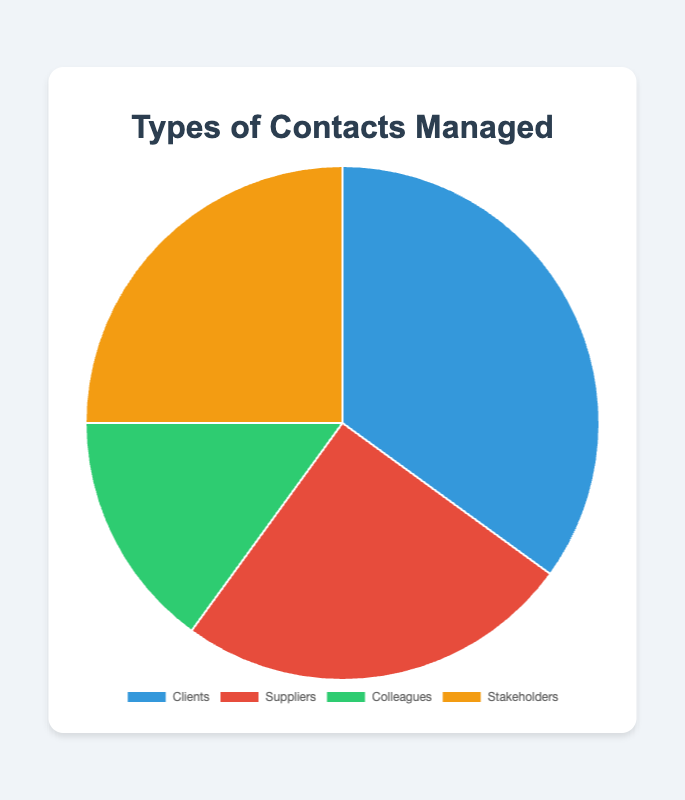What is the percentage of each contact type? From the visual, Clients, Suppliers, Colleagues, and Stakeholders are represented as slices of the pie chart. By looking at the tooltip or legend, you can directly see the percentage of each contact type.
Clients: 35/100*100 = 35%
Suppliers: 25/100*100 = 25%
Colleagues: 15/100*100 = 15%
Stakeholders: 25/100*100 = 25%
Answer: Clients: 35%, Suppliers: 25%, Colleagues: 15%, Stakeholders: 25% Which contact type has the highest percentage? By identifying the largest slice in the pie chart, it is evident that "Clients" take the largest portion.
Answer: Clients Is the percentage of Clients greater than that of Colleagues and Suppliers combined? Clients have 35%. Colleagues have 15%, and Suppliers have 25%. Adding the percentages of Colleagues and Suppliers gives 15% + 25% = 40%, which is greater than 35%.
Answer: No Are there any contact types with equal percentages? By comparing the sizes of slices, it is clear that "Suppliers" and "Stakeholders" both occupy 25% of the chart each.
Answer: Yes, Suppliers and Stakeholders What is the difference in percentage between the largest and smallest contact types? Clients represent 35%, and Colleagues represent 15%. By subtracting the smallest from the largest, 35% - 15% = 20%.
Answer: 20% What is the total percentage for non-client contacts? By adding up the percentages of Suppliers, Colleagues, and Stakeholders: 25% + 15% + 25% = 65%.
Answer: 65% What color is used to represent Stakeholders? By visually inspecting the pie chart, the color used for Stakeholders is orange.
Answer: Orange Which has a smaller percentage: Colleagues or Stakeholders? By comparing the slice sizes, Colleagues have 15% while Stakeholders have 25%, so Colleagues have a smaller percentage.
Answer: Colleagues If you combined Suppliers and Stakeholders, what percentage of the pie would they represent? Adding the percentages of Suppliers and Stakeholders gives 25% + 25% = 50%.
Answer: 50% What is the ratio of the percentage of Clients to Colleagues? Clients have 35% and Colleagues have 15%. The ratio is 35%/15% = 7/3, which can be simplified to 7:3.
Answer: 7:3 